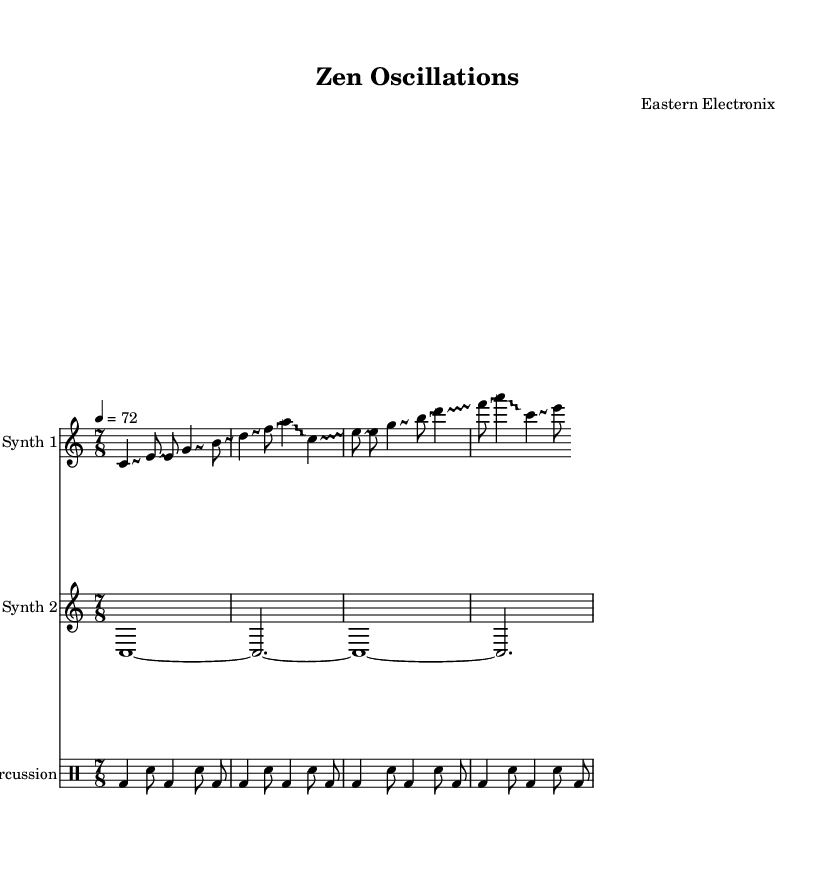What is the time signature of this piece? The time signature is indicated at the beginning of the score, showing there are seven beats in each measure.
Answer: 7/8 What is the tempo marking for the piece? The tempo marking is found at the beginning, stating that the piece should be played at a speed of 72 beats per minute.
Answer: 72 How many instruments are indicated in the score? The score displays three distinct musical staves for different instruments: two for synths and one for percussion, suggesting the presence of three instruments in total.
Answer: 3 What type of electronic music is represented in this score? The composition clearly embodies elements of microtonal electronic music influenced by ancient Eastern philosophies, characterized by experimental approaches and non-traditional tunings.
Answer: Microtonal electronic music What does the glissando indicate for the synthesizer parts? The glissando notation is present in the synth’s music, denoting that the notes should be played with a continuous slide between pitches rather than as distinct, separate tones.
Answer: Continuous slide How does the percussion pattern relate to the overall feel of the piece? The percussion follows a steady rhythmic pattern that complements the fluidity of the synthesizer parts, anchoring the experimental sound and enhancing the trance-like atmosphere typical of such compositions.
Answer: Steady rhythmic pattern 